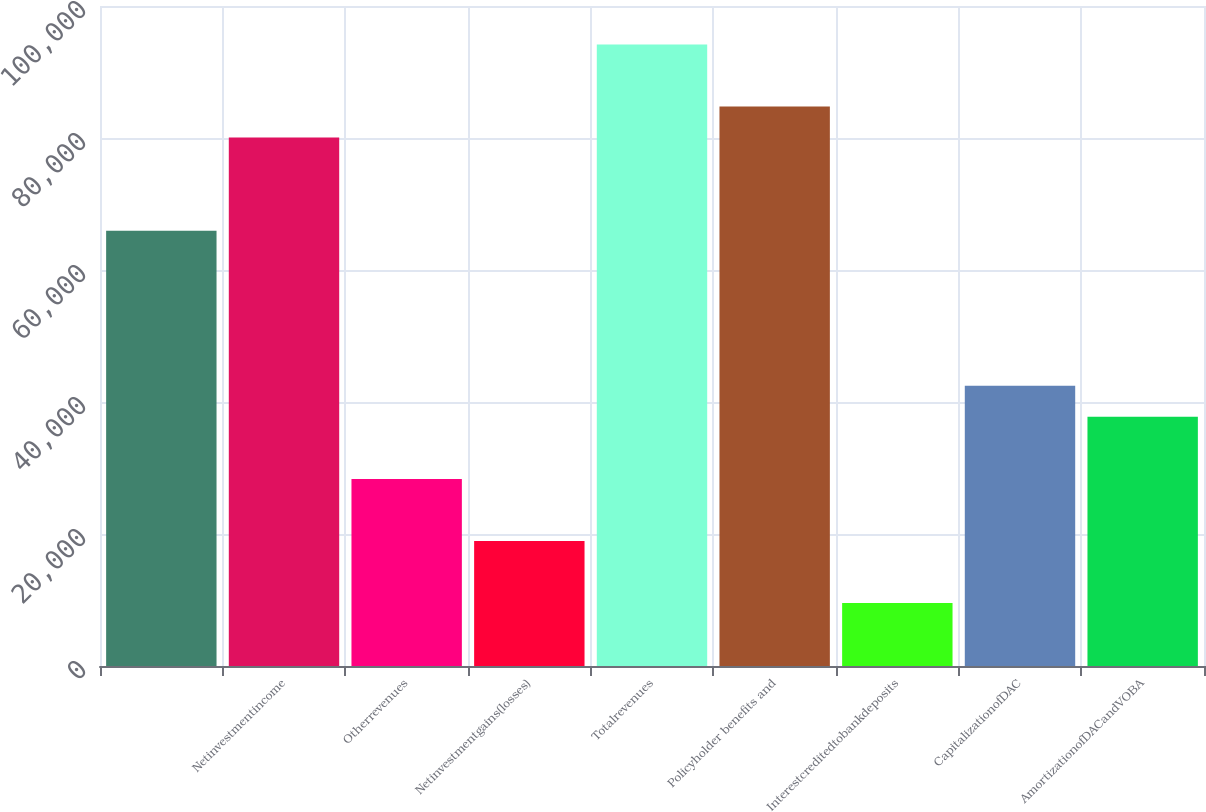<chart> <loc_0><loc_0><loc_500><loc_500><bar_chart><ecel><fcel>Netinvestmentincome<fcel>Otherrevenues<fcel>Netinvestmentgains(losses)<fcel>Totalrevenues<fcel>Policyholder benefits and<fcel>Interestcreditedtobankdeposits<fcel>CapitalizationofDAC<fcel>AmortizationofDACandVOBA<nl><fcel>65958<fcel>80062.5<fcel>28346<fcel>18943<fcel>94167<fcel>84764<fcel>9540<fcel>42450.5<fcel>37749<nl></chart> 